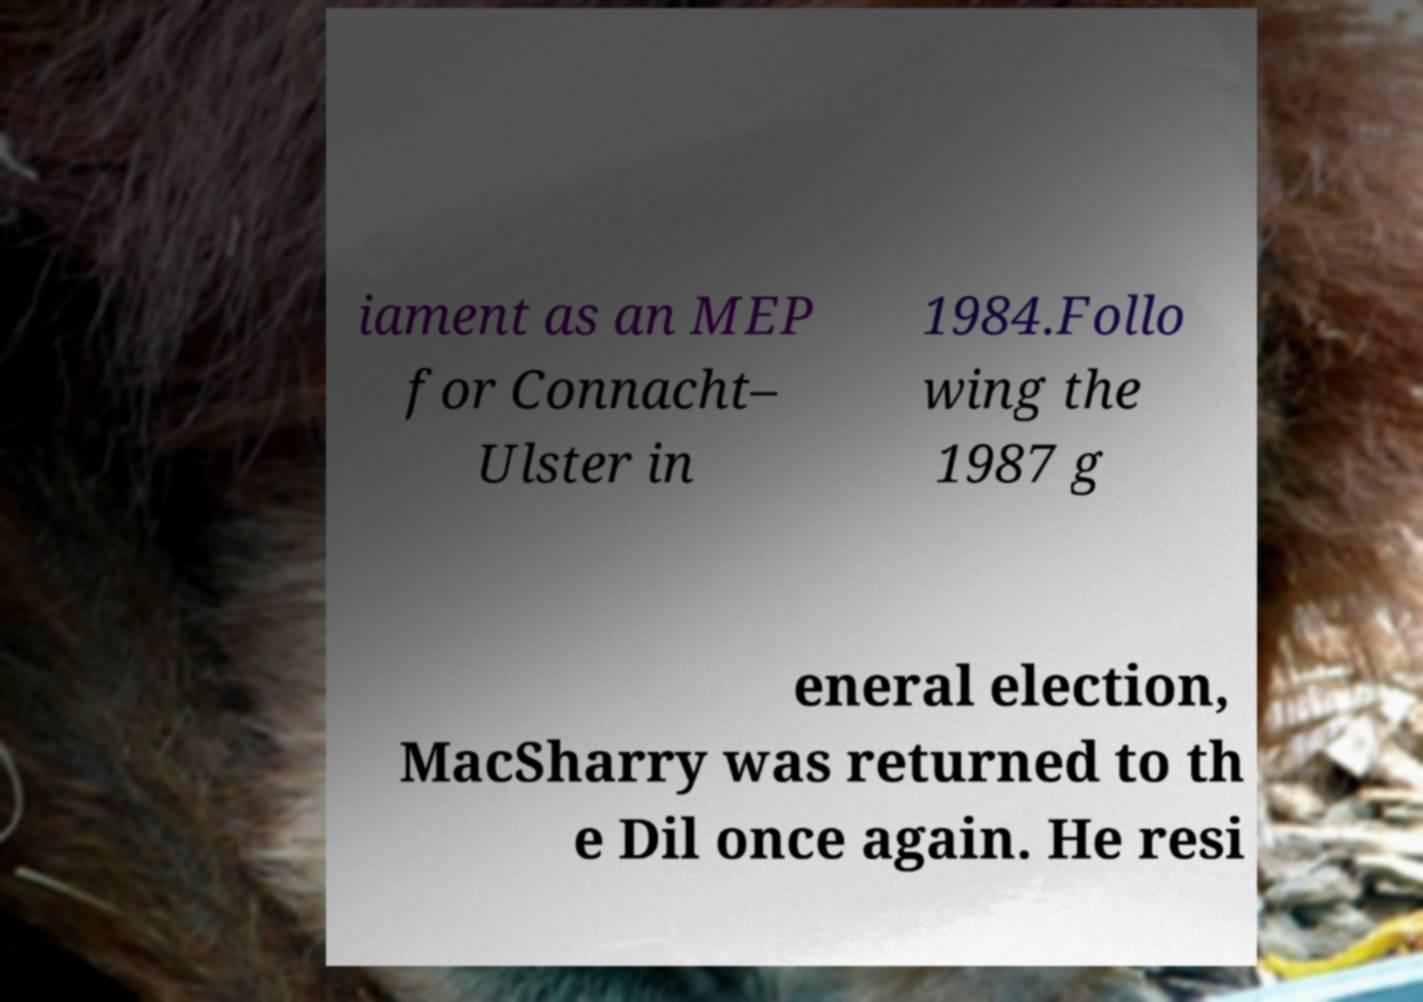Could you extract and type out the text from this image? iament as an MEP for Connacht– Ulster in 1984.Follo wing the 1987 g eneral election, MacSharry was returned to th e Dil once again. He resi 